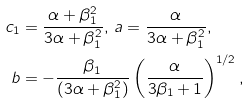Convert formula to latex. <formula><loc_0><loc_0><loc_500><loc_500>c _ { 1 } & = \frac { \alpha + \beta _ { 1 } ^ { 2 } } { 3 \alpha + \beta _ { 1 } ^ { 2 } } , \, a = \frac { \alpha } { 3 \alpha + \beta _ { 1 } ^ { 2 } } , \, \\ b & = - \frac { \beta _ { 1 } } { ( 3 \alpha + \beta _ { 1 } ^ { 2 } ) } \left ( \frac { \alpha } { 3 \beta _ { 1 } + 1 } \right ) ^ { 1 / 2 } ,</formula> 